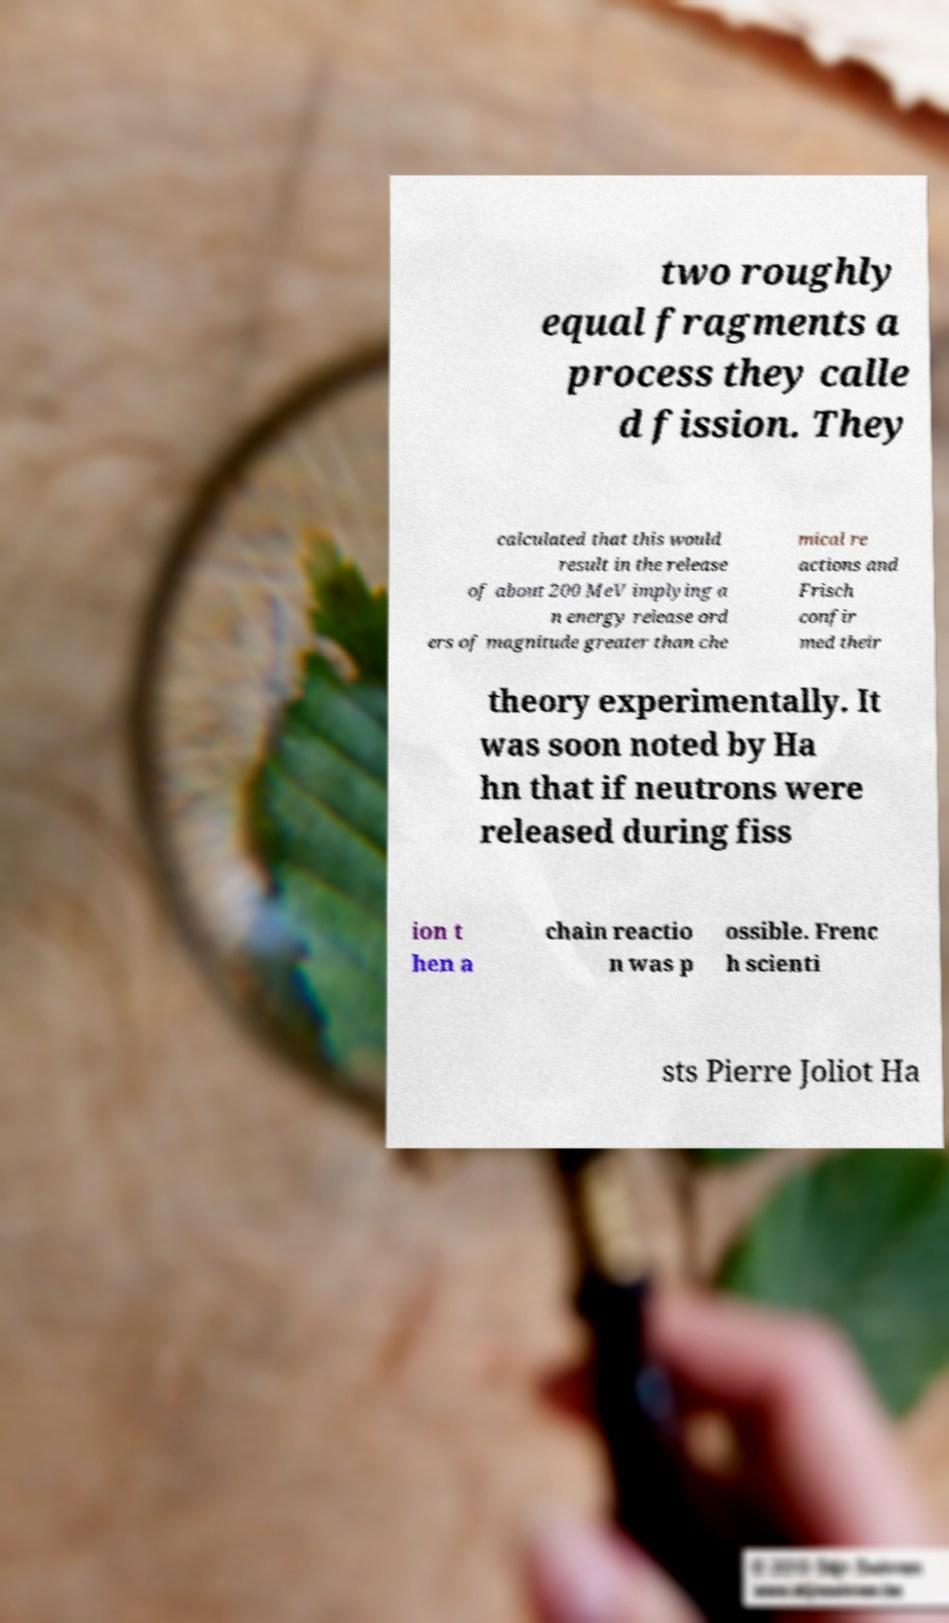For documentation purposes, I need the text within this image transcribed. Could you provide that? two roughly equal fragments a process they calle d fission. They calculated that this would result in the release of about 200 MeV implying a n energy release ord ers of magnitude greater than che mical re actions and Frisch confir med their theory experimentally. It was soon noted by Ha hn that if neutrons were released during fiss ion t hen a chain reactio n was p ossible. Frenc h scienti sts Pierre Joliot Ha 